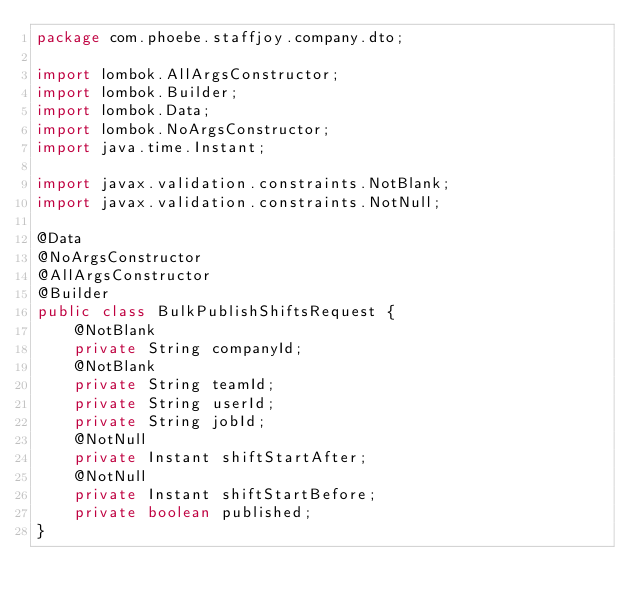<code> <loc_0><loc_0><loc_500><loc_500><_Java_>package com.phoebe.staffjoy.company.dto;

import lombok.AllArgsConstructor;
import lombok.Builder;
import lombok.Data;
import lombok.NoArgsConstructor;
import java.time.Instant;

import javax.validation.constraints.NotBlank;
import javax.validation.constraints.NotNull;

@Data
@NoArgsConstructor
@AllArgsConstructor
@Builder
public class BulkPublishShiftsRequest {
    @NotBlank
    private String companyId;
    @NotBlank
    private String teamId;
    private String userId;
    private String jobId;
    @NotNull
    private Instant shiftStartAfter;
    @NotNull
    private Instant shiftStartBefore;
    private boolean published;
}
</code> 